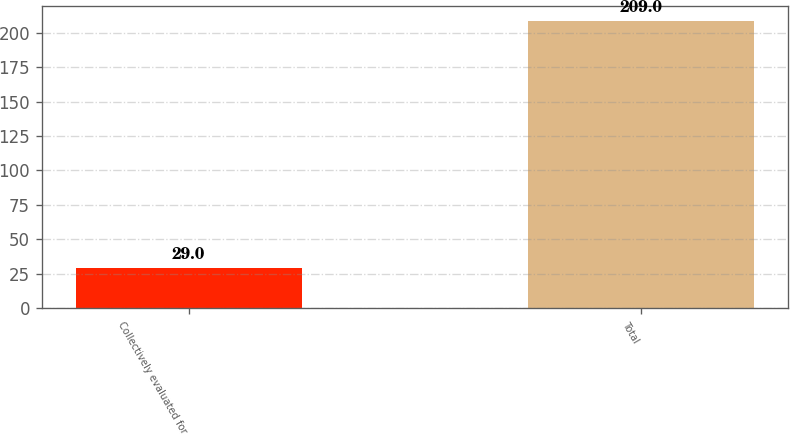Convert chart. <chart><loc_0><loc_0><loc_500><loc_500><bar_chart><fcel>Collectively evaluated for<fcel>Total<nl><fcel>29<fcel>209<nl></chart> 